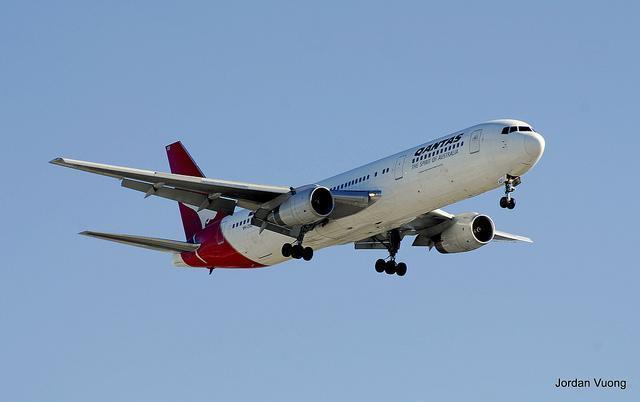How many wheels can be seen on the plane?
Give a very brief answer. 8. 